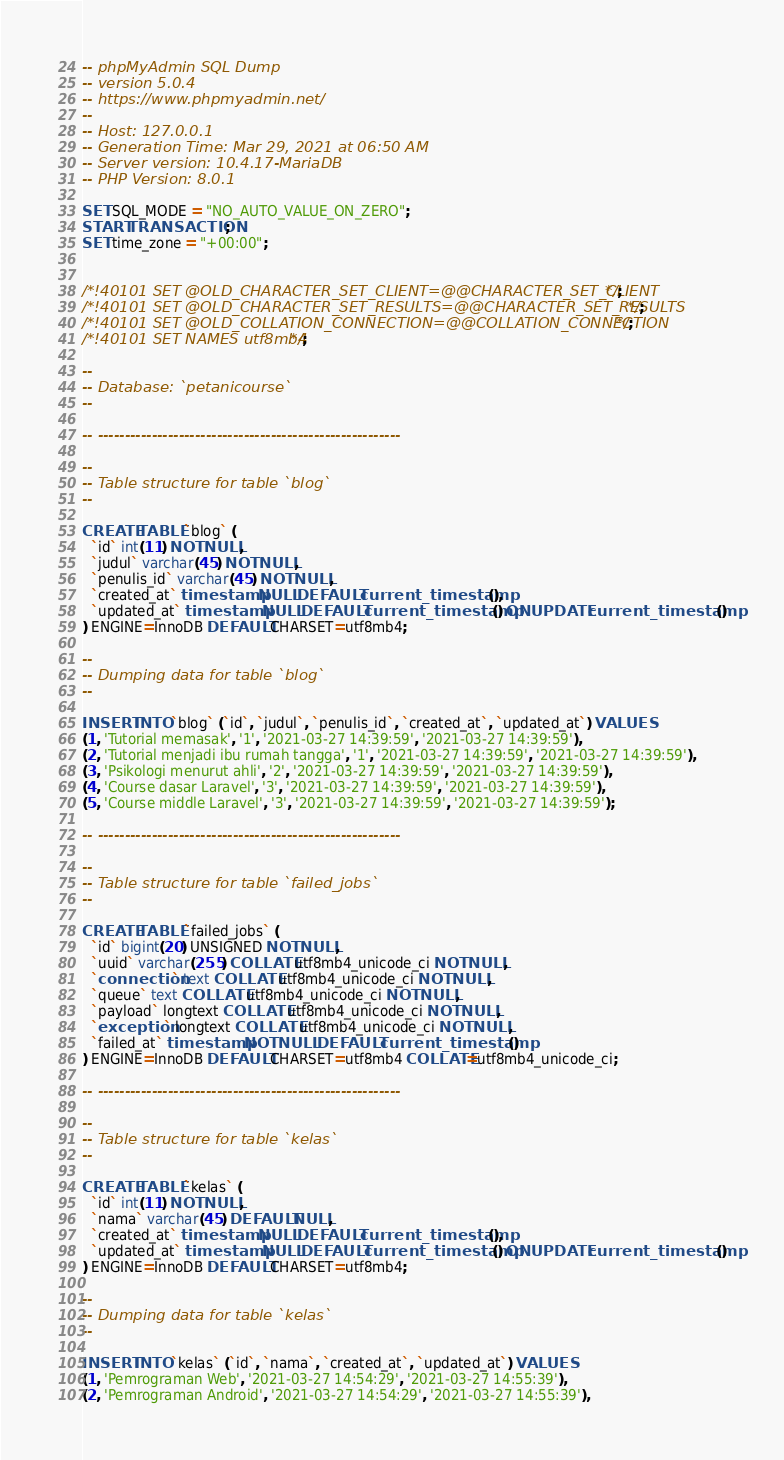Convert code to text. <code><loc_0><loc_0><loc_500><loc_500><_SQL_>-- phpMyAdmin SQL Dump
-- version 5.0.4
-- https://www.phpmyadmin.net/
--
-- Host: 127.0.0.1
-- Generation Time: Mar 29, 2021 at 06:50 AM
-- Server version: 10.4.17-MariaDB
-- PHP Version: 8.0.1

SET SQL_MODE = "NO_AUTO_VALUE_ON_ZERO";
START TRANSACTION;
SET time_zone = "+00:00";


/*!40101 SET @OLD_CHARACTER_SET_CLIENT=@@CHARACTER_SET_CLIENT */;
/*!40101 SET @OLD_CHARACTER_SET_RESULTS=@@CHARACTER_SET_RESULTS */;
/*!40101 SET @OLD_COLLATION_CONNECTION=@@COLLATION_CONNECTION */;
/*!40101 SET NAMES utf8mb4 */;

--
-- Database: `petanicourse`
--

-- --------------------------------------------------------

--
-- Table structure for table `blog`
--

CREATE TABLE `blog` (
  `id` int(11) NOT NULL,
  `judul` varchar(45) NOT NULL,
  `penulis_id` varchar(45) NOT NULL,
  `created_at` timestamp NULL DEFAULT current_timestamp(),
  `updated_at` timestamp NULL DEFAULT current_timestamp() ON UPDATE current_timestamp()
) ENGINE=InnoDB DEFAULT CHARSET=utf8mb4;

--
-- Dumping data for table `blog`
--

INSERT INTO `blog` (`id`, `judul`, `penulis_id`, `created_at`, `updated_at`) VALUES
(1, 'Tutorial memasak', '1', '2021-03-27 14:39:59', '2021-03-27 14:39:59'),
(2, 'Tutorial menjadi ibu rumah tangga', '1', '2021-03-27 14:39:59', '2021-03-27 14:39:59'),
(3, 'Psikologi menurut ahli', '2', '2021-03-27 14:39:59', '2021-03-27 14:39:59'),
(4, 'Course dasar Laravel', '3', '2021-03-27 14:39:59', '2021-03-27 14:39:59'),
(5, 'Course middle Laravel', '3', '2021-03-27 14:39:59', '2021-03-27 14:39:59');

-- --------------------------------------------------------

--
-- Table structure for table `failed_jobs`
--

CREATE TABLE `failed_jobs` (
  `id` bigint(20) UNSIGNED NOT NULL,
  `uuid` varchar(255) COLLATE utf8mb4_unicode_ci NOT NULL,
  `connection` text COLLATE utf8mb4_unicode_ci NOT NULL,
  `queue` text COLLATE utf8mb4_unicode_ci NOT NULL,
  `payload` longtext COLLATE utf8mb4_unicode_ci NOT NULL,
  `exception` longtext COLLATE utf8mb4_unicode_ci NOT NULL,
  `failed_at` timestamp NOT NULL DEFAULT current_timestamp()
) ENGINE=InnoDB DEFAULT CHARSET=utf8mb4 COLLATE=utf8mb4_unicode_ci;

-- --------------------------------------------------------

--
-- Table structure for table `kelas`
--

CREATE TABLE `kelas` (
  `id` int(11) NOT NULL,
  `nama` varchar(45) DEFAULT NULL,
  `created_at` timestamp NULL DEFAULT current_timestamp(),
  `updated_at` timestamp NULL DEFAULT current_timestamp() ON UPDATE current_timestamp()
) ENGINE=InnoDB DEFAULT CHARSET=utf8mb4;

--
-- Dumping data for table `kelas`
--

INSERT INTO `kelas` (`id`, `nama`, `created_at`, `updated_at`) VALUES
(1, 'Pemrograman Web', '2021-03-27 14:54:29', '2021-03-27 14:55:39'),
(2, 'Pemrograman Android', '2021-03-27 14:54:29', '2021-03-27 14:55:39'),</code> 